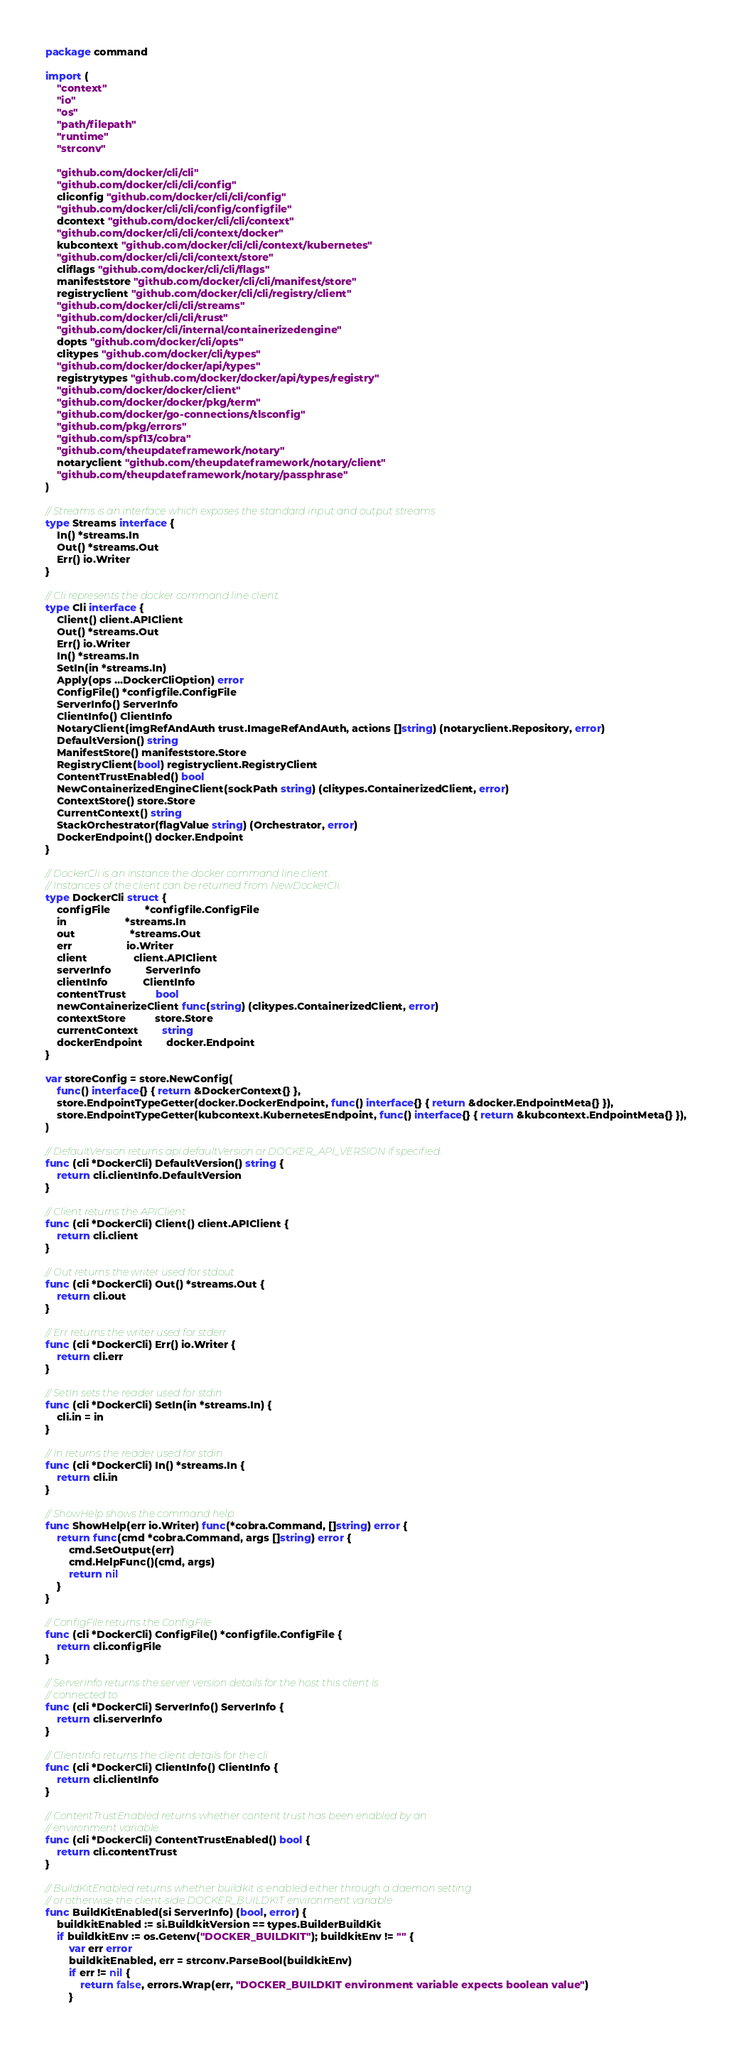<code> <loc_0><loc_0><loc_500><loc_500><_Go_>package command

import (
	"context"
	"io"
	"os"
	"path/filepath"
	"runtime"
	"strconv"

	"github.com/docker/cli/cli"
	"github.com/docker/cli/cli/config"
	cliconfig "github.com/docker/cli/cli/config"
	"github.com/docker/cli/cli/config/configfile"
	dcontext "github.com/docker/cli/cli/context"
	"github.com/docker/cli/cli/context/docker"
	kubcontext "github.com/docker/cli/cli/context/kubernetes"
	"github.com/docker/cli/cli/context/store"
	cliflags "github.com/docker/cli/cli/flags"
	manifeststore "github.com/docker/cli/cli/manifest/store"
	registryclient "github.com/docker/cli/cli/registry/client"
	"github.com/docker/cli/cli/streams"
	"github.com/docker/cli/cli/trust"
	"github.com/docker/cli/internal/containerizedengine"
	dopts "github.com/docker/cli/opts"
	clitypes "github.com/docker/cli/types"
	"github.com/docker/docker/api/types"
	registrytypes "github.com/docker/docker/api/types/registry"
	"github.com/docker/docker/client"
	"github.com/docker/docker/pkg/term"
	"github.com/docker/go-connections/tlsconfig"
	"github.com/pkg/errors"
	"github.com/spf13/cobra"
	"github.com/theupdateframework/notary"
	notaryclient "github.com/theupdateframework/notary/client"
	"github.com/theupdateframework/notary/passphrase"
)

// Streams is an interface which exposes the standard input and output streams
type Streams interface {
	In() *streams.In
	Out() *streams.Out
	Err() io.Writer
}

// Cli represents the docker command line client.
type Cli interface {
	Client() client.APIClient
	Out() *streams.Out
	Err() io.Writer
	In() *streams.In
	SetIn(in *streams.In)
	Apply(ops ...DockerCliOption) error
	ConfigFile() *configfile.ConfigFile
	ServerInfo() ServerInfo
	ClientInfo() ClientInfo
	NotaryClient(imgRefAndAuth trust.ImageRefAndAuth, actions []string) (notaryclient.Repository, error)
	DefaultVersion() string
	ManifestStore() manifeststore.Store
	RegistryClient(bool) registryclient.RegistryClient
	ContentTrustEnabled() bool
	NewContainerizedEngineClient(sockPath string) (clitypes.ContainerizedClient, error)
	ContextStore() store.Store
	CurrentContext() string
	StackOrchestrator(flagValue string) (Orchestrator, error)
	DockerEndpoint() docker.Endpoint
}

// DockerCli is an instance the docker command line client.
// Instances of the client can be returned from NewDockerCli.
type DockerCli struct {
	configFile            *configfile.ConfigFile
	in                    *streams.In
	out                   *streams.Out
	err                   io.Writer
	client                client.APIClient
	serverInfo            ServerInfo
	clientInfo            ClientInfo
	contentTrust          bool
	newContainerizeClient func(string) (clitypes.ContainerizedClient, error)
	contextStore          store.Store
	currentContext        string
	dockerEndpoint        docker.Endpoint
}

var storeConfig = store.NewConfig(
	func() interface{} { return &DockerContext{} },
	store.EndpointTypeGetter(docker.DockerEndpoint, func() interface{} { return &docker.EndpointMeta{} }),
	store.EndpointTypeGetter(kubcontext.KubernetesEndpoint, func() interface{} { return &kubcontext.EndpointMeta{} }),
)

// DefaultVersion returns api.defaultVersion or DOCKER_API_VERSION if specified.
func (cli *DockerCli) DefaultVersion() string {
	return cli.clientInfo.DefaultVersion
}

// Client returns the APIClient
func (cli *DockerCli) Client() client.APIClient {
	return cli.client
}

// Out returns the writer used for stdout
func (cli *DockerCli) Out() *streams.Out {
	return cli.out
}

// Err returns the writer used for stderr
func (cli *DockerCli) Err() io.Writer {
	return cli.err
}

// SetIn sets the reader used for stdin
func (cli *DockerCli) SetIn(in *streams.In) {
	cli.in = in
}

// In returns the reader used for stdin
func (cli *DockerCli) In() *streams.In {
	return cli.in
}

// ShowHelp shows the command help.
func ShowHelp(err io.Writer) func(*cobra.Command, []string) error {
	return func(cmd *cobra.Command, args []string) error {
		cmd.SetOutput(err)
		cmd.HelpFunc()(cmd, args)
		return nil
	}
}

// ConfigFile returns the ConfigFile
func (cli *DockerCli) ConfigFile() *configfile.ConfigFile {
	return cli.configFile
}

// ServerInfo returns the server version details for the host this client is
// connected to
func (cli *DockerCli) ServerInfo() ServerInfo {
	return cli.serverInfo
}

// ClientInfo returns the client details for the cli
func (cli *DockerCli) ClientInfo() ClientInfo {
	return cli.clientInfo
}

// ContentTrustEnabled returns whether content trust has been enabled by an
// environment variable.
func (cli *DockerCli) ContentTrustEnabled() bool {
	return cli.contentTrust
}

// BuildKitEnabled returns whether buildkit is enabled either through a daemon setting
// or otherwise the client-side DOCKER_BUILDKIT environment variable
func BuildKitEnabled(si ServerInfo) (bool, error) {
	buildkitEnabled := si.BuildkitVersion == types.BuilderBuildKit
	if buildkitEnv := os.Getenv("DOCKER_BUILDKIT"); buildkitEnv != "" {
		var err error
		buildkitEnabled, err = strconv.ParseBool(buildkitEnv)
		if err != nil {
			return false, errors.Wrap(err, "DOCKER_BUILDKIT environment variable expects boolean value")
		}</code> 